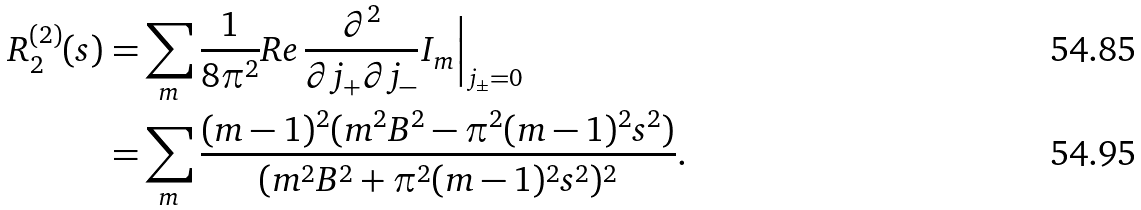<formula> <loc_0><loc_0><loc_500><loc_500>R ^ { ( 2 ) } _ { 2 } ( s ) = & \sum _ { m } \frac { 1 } { 8 \pi ^ { 2 } } R e \, \frac { \partial ^ { 2 } } { \partial j _ { + } \partial j _ { - } } I _ { m } \Big | _ { j _ { \pm } = 0 } \\ = & \sum _ { m } \frac { ( m - 1 ) ^ { 2 } ( m ^ { 2 } B ^ { 2 } - \pi ^ { 2 } ( m - 1 ) ^ { 2 } s ^ { 2 } ) } { ( m ^ { 2 } B ^ { 2 } + \pi ^ { 2 } ( m - 1 ) ^ { 2 } s ^ { 2 } ) ^ { 2 } } .</formula> 